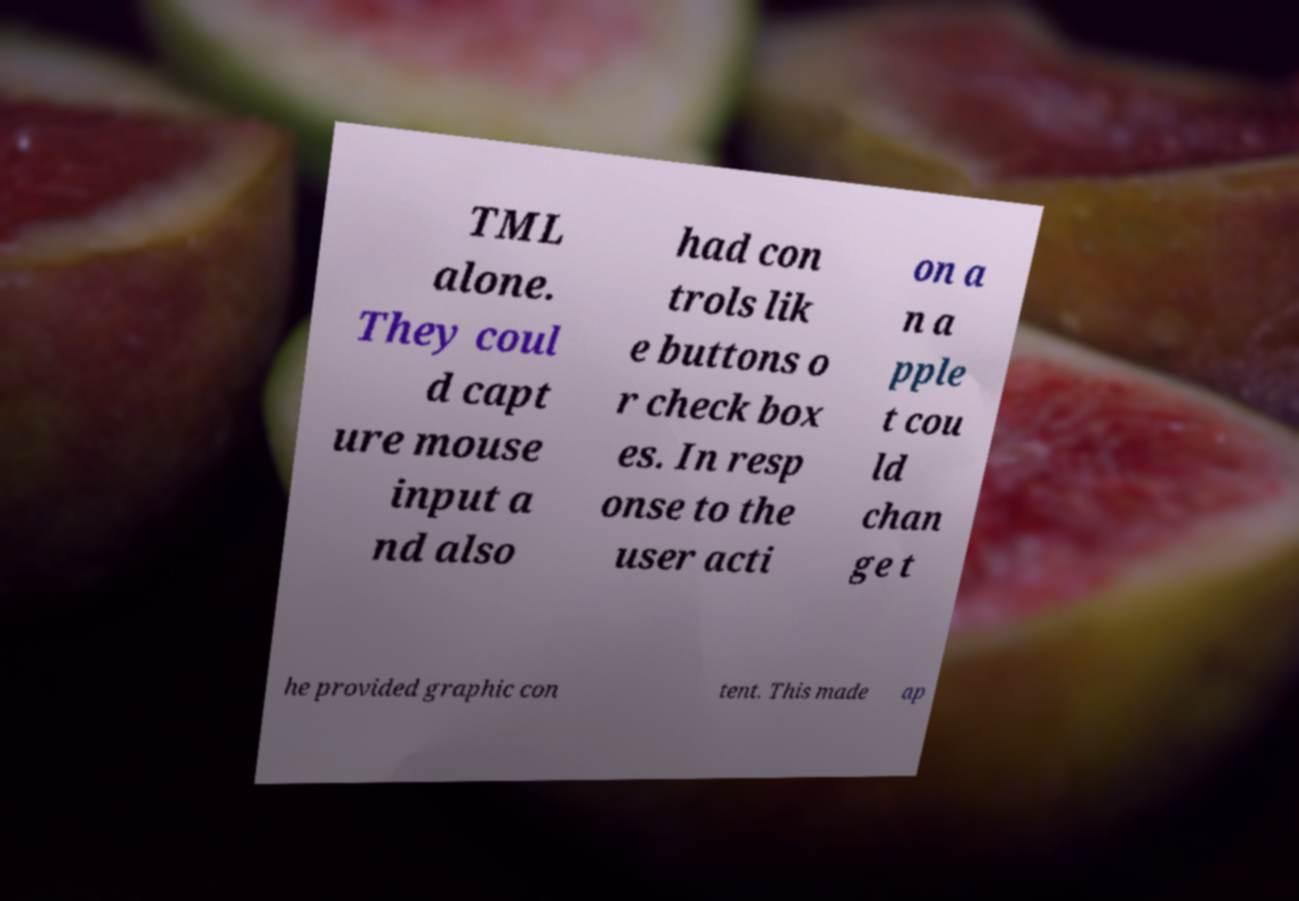Can you accurately transcribe the text from the provided image for me? TML alone. They coul d capt ure mouse input a nd also had con trols lik e buttons o r check box es. In resp onse to the user acti on a n a pple t cou ld chan ge t he provided graphic con tent. This made ap 